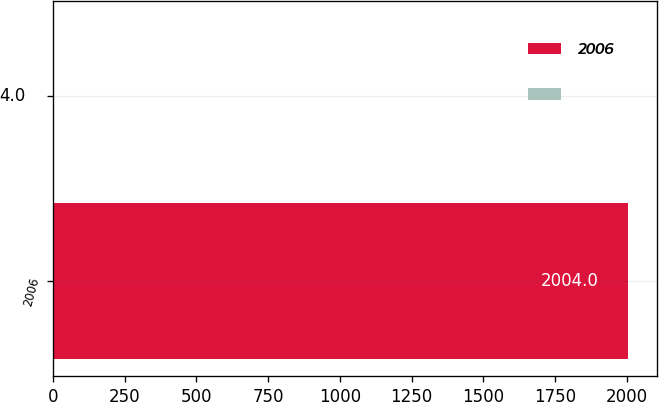Convert chart to OTSL. <chart><loc_0><loc_0><loc_500><loc_500><bar_chart><fcel>2006<fcel>Unnamed: 1<nl><fcel>2004<fcel>4<nl></chart> 